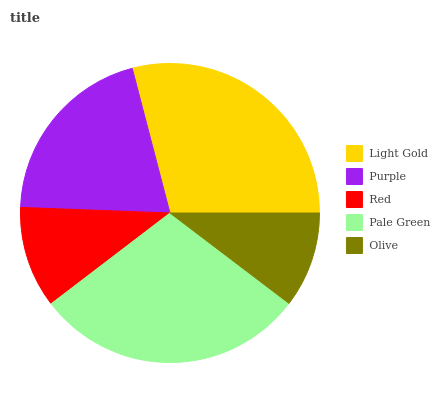Is Olive the minimum?
Answer yes or no. Yes. Is Pale Green the maximum?
Answer yes or no. Yes. Is Purple the minimum?
Answer yes or no. No. Is Purple the maximum?
Answer yes or no. No. Is Light Gold greater than Purple?
Answer yes or no. Yes. Is Purple less than Light Gold?
Answer yes or no. Yes. Is Purple greater than Light Gold?
Answer yes or no. No. Is Light Gold less than Purple?
Answer yes or no. No. Is Purple the high median?
Answer yes or no. Yes. Is Purple the low median?
Answer yes or no. Yes. Is Red the high median?
Answer yes or no. No. Is Olive the low median?
Answer yes or no. No. 